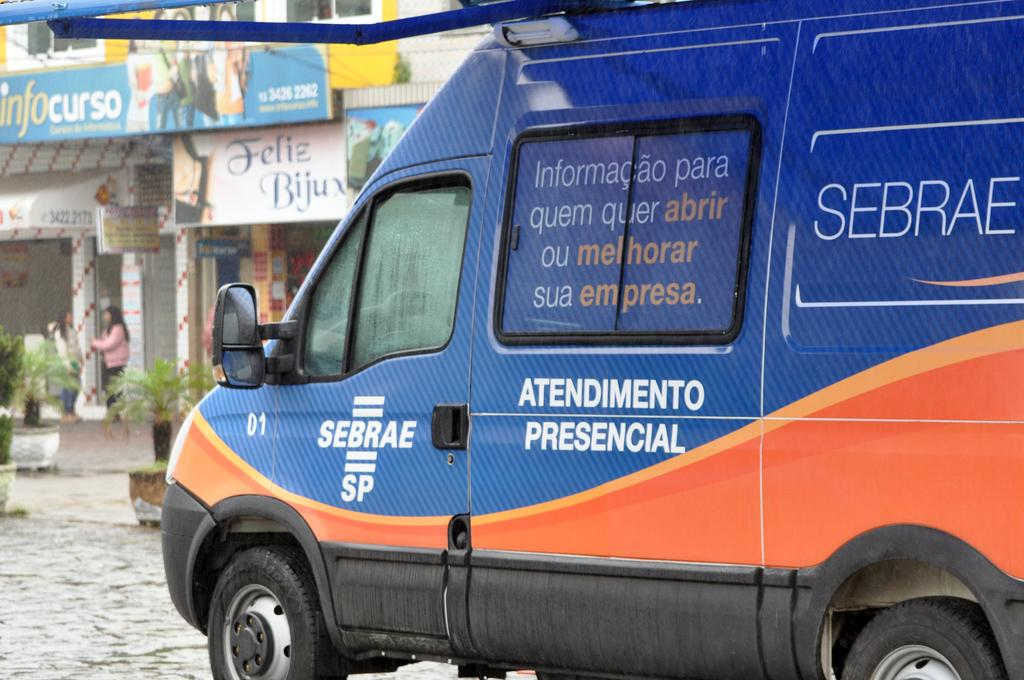<image>
Provide a brief description of the given image. A blue and orange van that says Atendimento Presencial on its side drives through the street. 